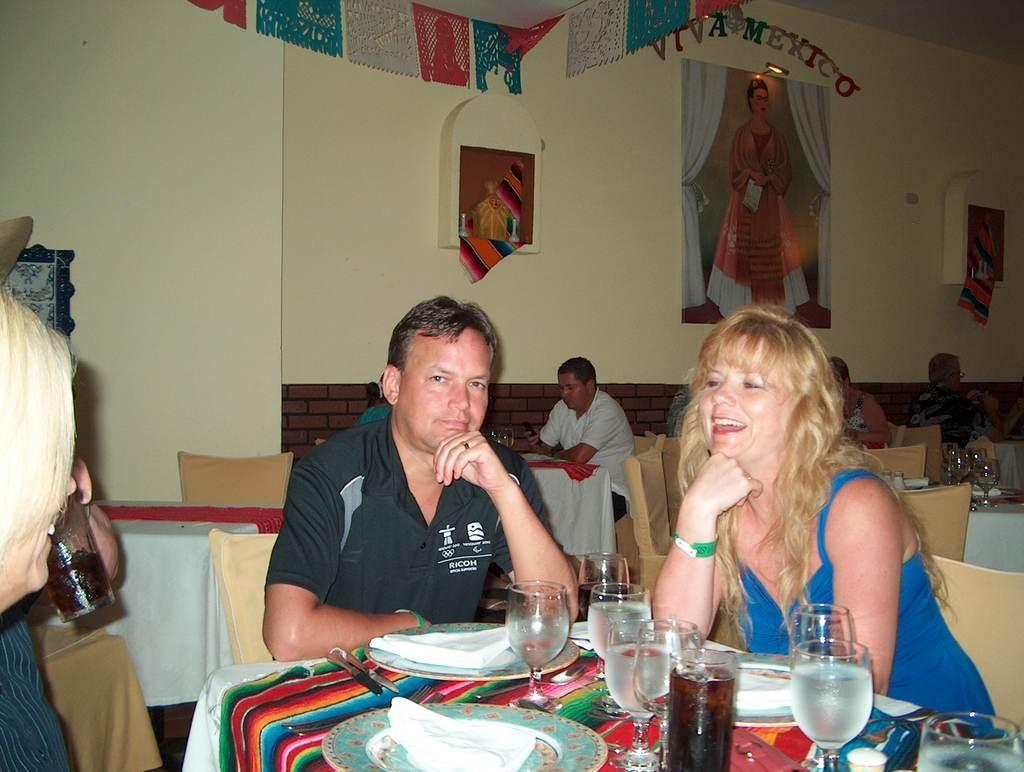Could you give a brief overview of what you see in this image? In this picture we can see a man wearing black t-shirt sitting on the chair and giving a pose to the camera. Beside there is a woman wearing a blue dress and smiling. Behind there are some people sitting at the restaurant table. In the background we can see walls with some decoration ribbons.  